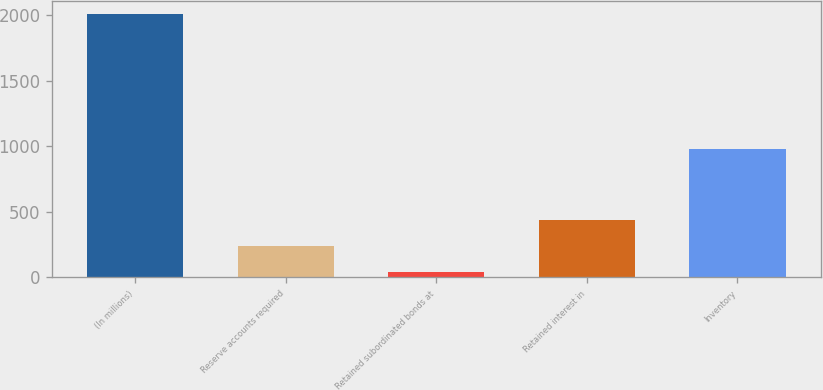Convert chart to OTSL. <chart><loc_0><loc_0><loc_500><loc_500><bar_chart><fcel>(In millions)<fcel>Reserve accounts required<fcel>Retained subordinated bonds at<fcel>Retained interest in<fcel>Inventory<nl><fcel>2008<fcel>239.59<fcel>43.1<fcel>436.08<fcel>975.8<nl></chart> 